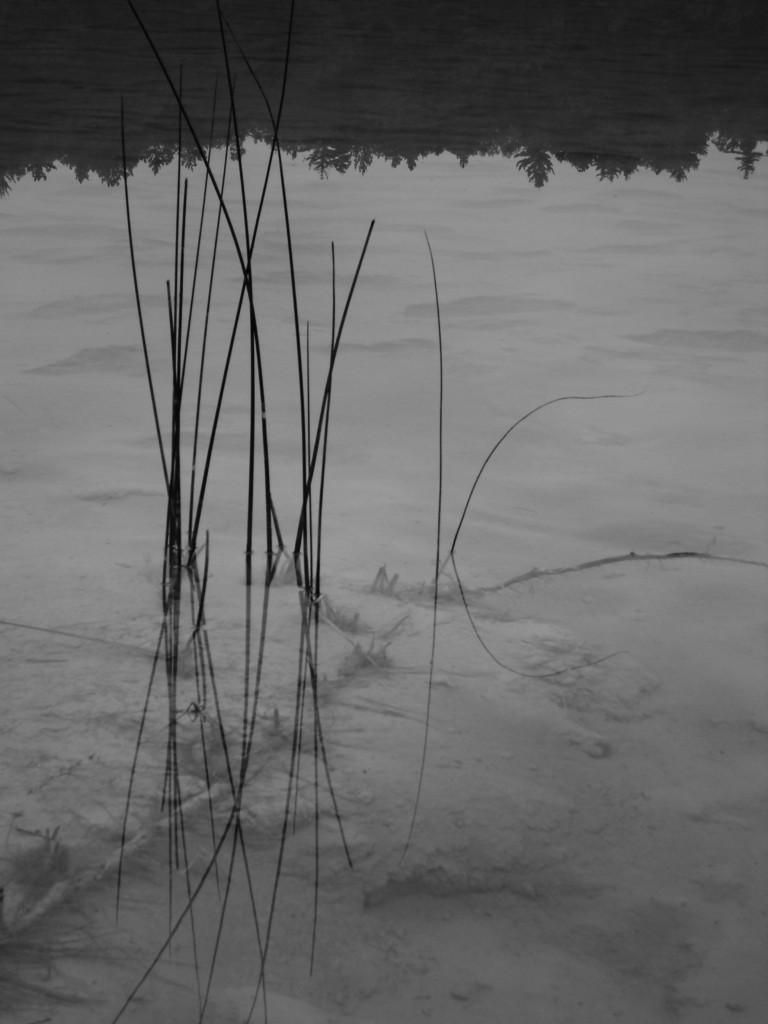In one or two sentences, can you explain what this image depicts? In this image I can see the water, on the water I can see the reflection of trees. I can see few black colored objects in the water. 